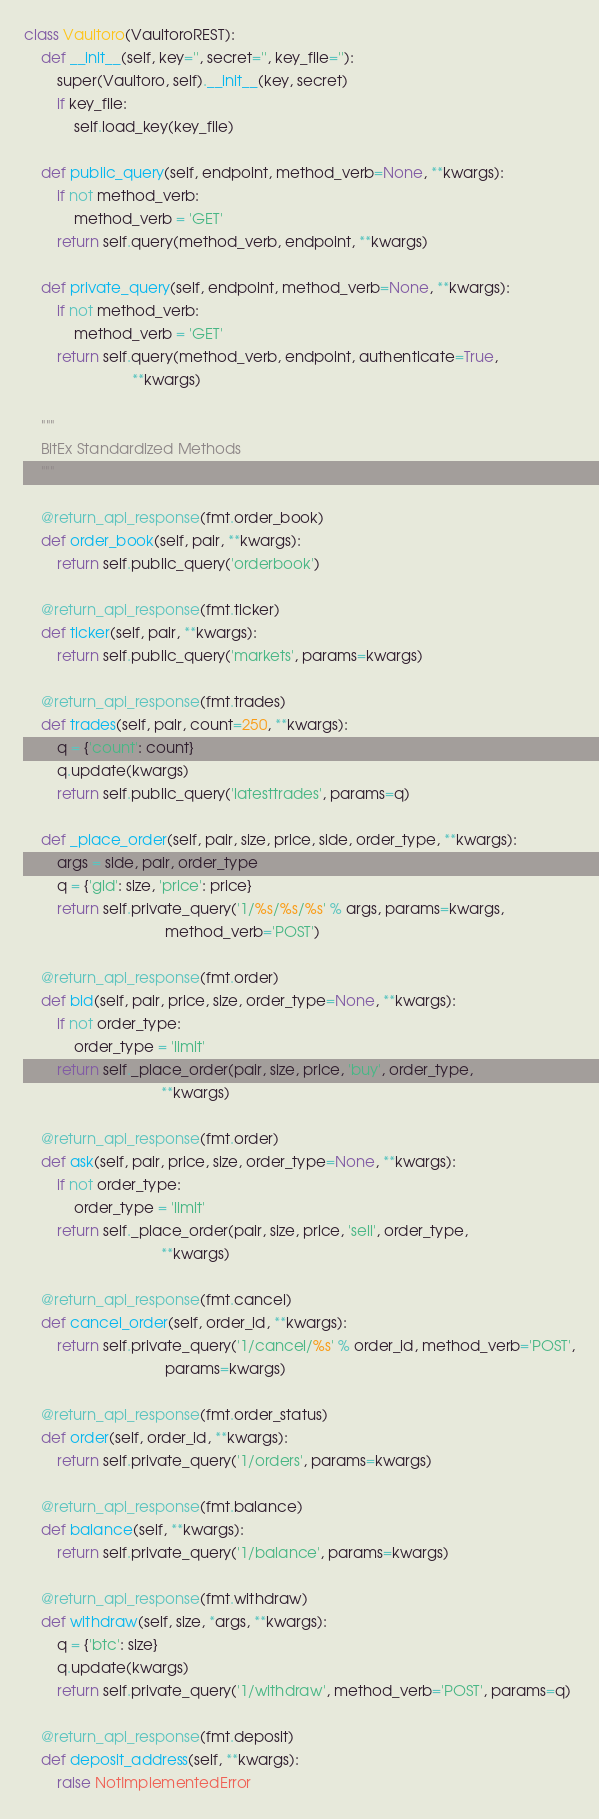Convert code to text. <code><loc_0><loc_0><loc_500><loc_500><_Python_>
class Vaultoro(VaultoroREST):
    def __init__(self, key='', secret='', key_file=''):
        super(Vaultoro, self).__init__(key, secret)
        if key_file:
            self.load_key(key_file)

    def public_query(self, endpoint, method_verb=None, **kwargs):
        if not method_verb:
            method_verb = 'GET'
        return self.query(method_verb, endpoint, **kwargs)

    def private_query(self, endpoint, method_verb=None, **kwargs):
        if not method_verb:
            method_verb = 'GET'
        return self.query(method_verb, endpoint, authenticate=True,
                          **kwargs)

    """
    BitEx Standardized Methods
    """

    @return_api_response(fmt.order_book)
    def order_book(self, pair, **kwargs):
        return self.public_query('orderbook')

    @return_api_response(fmt.ticker)
    def ticker(self, pair, **kwargs):
        return self.public_query('markets', params=kwargs)

    @return_api_response(fmt.trades)
    def trades(self, pair, count=250, **kwargs):
        q = {'count': count}
        q.update(kwargs)
        return self.public_query('latesttrades', params=q)

    def _place_order(self, pair, size, price, side, order_type, **kwargs):
        args = side, pair, order_type
        q = {'gld': size, 'price': price}
        return self.private_query('1/%s/%s/%s' % args, params=kwargs,
                                  method_verb='POST')

    @return_api_response(fmt.order)
    def bid(self, pair, price, size, order_type=None, **kwargs):
        if not order_type:
            order_type = 'limit'
        return self._place_order(pair, size, price, 'buy', order_type,
                                 **kwargs)

    @return_api_response(fmt.order)
    def ask(self, pair, price, size, order_type=None, **kwargs):
        if not order_type:
            order_type = 'limit'
        return self._place_order(pair, size, price, 'sell', order_type,
                                 **kwargs)

    @return_api_response(fmt.cancel)
    def cancel_order(self, order_id, **kwargs):
        return self.private_query('1/cancel/%s' % order_id, method_verb='POST',
                                  params=kwargs)

    @return_api_response(fmt.order_status)
    def order(self, order_id, **kwargs):
        return self.private_query('1/orders', params=kwargs)

    @return_api_response(fmt.balance)
    def balance(self, **kwargs):
        return self.private_query('1/balance', params=kwargs)

    @return_api_response(fmt.withdraw)
    def withdraw(self, size, *args, **kwargs):
        q = {'btc': size}
        q.update(kwargs)
        return self.private_query('1/withdraw', method_verb='POST', params=q)

    @return_api_response(fmt.deposit)
    def deposit_address(self, **kwargs):
        raise NotImplementedError</code> 